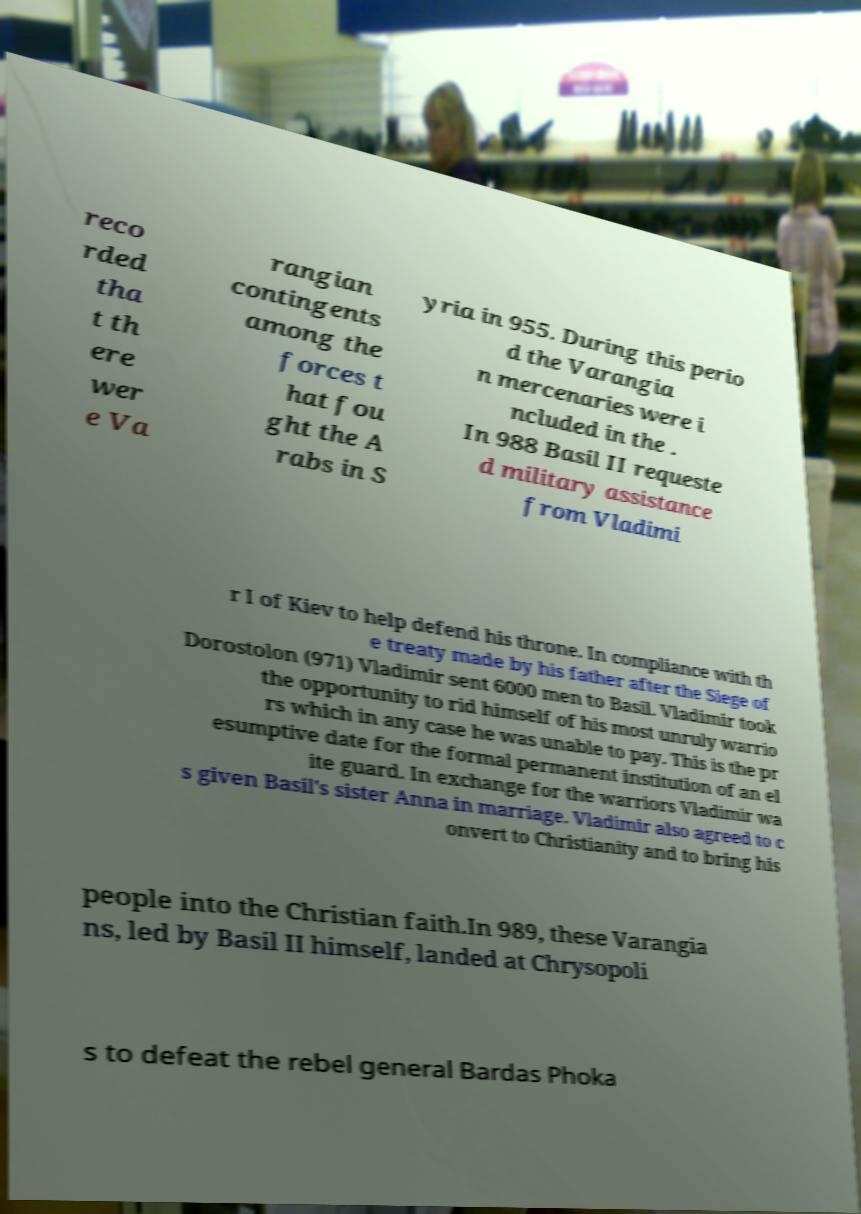Can you accurately transcribe the text from the provided image for me? reco rded tha t th ere wer e Va rangian contingents among the forces t hat fou ght the A rabs in S yria in 955. During this perio d the Varangia n mercenaries were i ncluded in the . In 988 Basil II requeste d military assistance from Vladimi r I of Kiev to help defend his throne. In compliance with th e treaty made by his father after the Siege of Dorostolon (971) Vladimir sent 6000 men to Basil. Vladimir took the opportunity to rid himself of his most unruly warrio rs which in any case he was unable to pay. This is the pr esumptive date for the formal permanent institution of an el ite guard. In exchange for the warriors Vladimir wa s given Basil's sister Anna in marriage. Vladimir also agreed to c onvert to Christianity and to bring his people into the Christian faith.In 989, these Varangia ns, led by Basil II himself, landed at Chrysopoli s to defeat the rebel general Bardas Phoka 